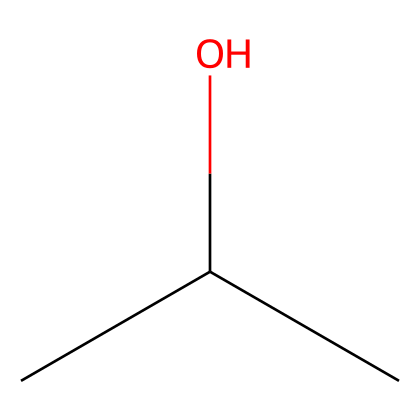How many carbon atoms are in isopropyl alcohol? The SMILES representation (CC(C)O) indicates three 'C' atoms, representing three carbon atoms in total.
Answer: three What type of functional group is present in isopropyl alcohol? The 'O' in the SMILES representation (CC(C)O) signifies the presence of an alcohol functional group, which is characterized by a hydroxyl group (-OH).
Answer: alcohol How many hydrogen atoms are bonded to the carbon atoms in isopropyl alcohol? Each carbon typically forms four bonds. The first two carbons (from left) are each bonded to three hydrogens, and the last carbon is connected to one hydrogen (due to the hydroxyl group). Therefore, total hydrogen = 3 + 3 + 1 = 7.
Answer: seven What is the structural formula of isopropyl alcohol? The SMILES structure (CC(C)O) corresponds to a three-carbon chain with a hydroxyl group on the second carbon, indicating its structural arrangement as (CH3)2CHOH.
Answer: (CH3)2CHOH Is isopropyl alcohol considered a flammable liquid? Isopropyl alcohol is classified as a flammable liquid due to its low flash point and ability to ignite easily when exposed to flame or heat.
Answer: yes What type of chemical bond connects the carbon atoms in isopropyl alcohol? The carbon atoms in isopropyl alcohol are connected by covalent bonds, where atoms share electrons to achieve stability.
Answer: covalent What property of isopropyl alcohol makes it effective for cleaning computer screens? Isopropyl alcohol has excellent solvent properties, allowing it to effectively dissolve oils and grime, making it ideal for cleaning surfaces without leaving residue.
Answer: solvent 